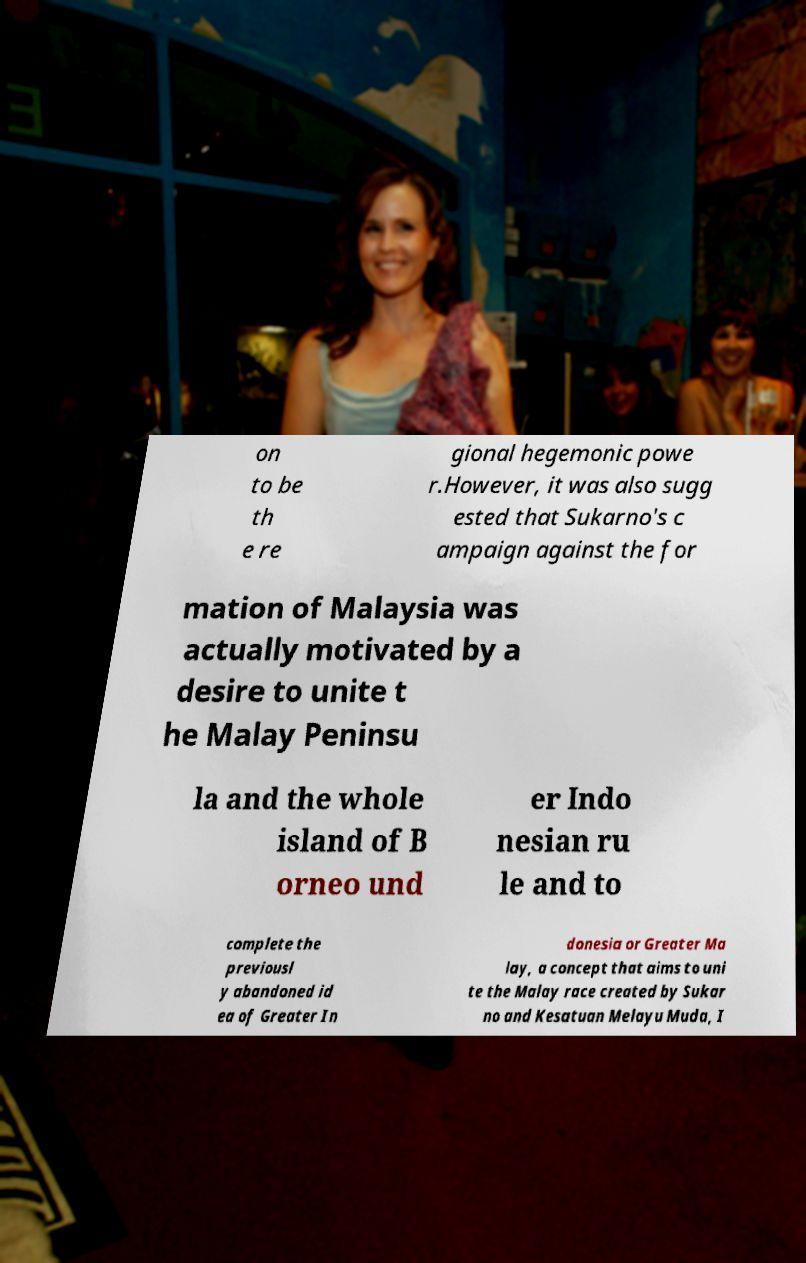Can you read and provide the text displayed in the image?This photo seems to have some interesting text. Can you extract and type it out for me? on to be th e re gional hegemonic powe r.However, it was also sugg ested that Sukarno's c ampaign against the for mation of Malaysia was actually motivated by a desire to unite t he Malay Peninsu la and the whole island of B orneo und er Indo nesian ru le and to complete the previousl y abandoned id ea of Greater In donesia or Greater Ma lay, a concept that aims to uni te the Malay race created by Sukar no and Kesatuan Melayu Muda, I 